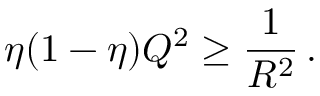<formula> <loc_0><loc_0><loc_500><loc_500>\eta ( 1 - \eta ) Q ^ { 2 } \geq \frac { 1 } R ^ { 2 } } \, .</formula> 